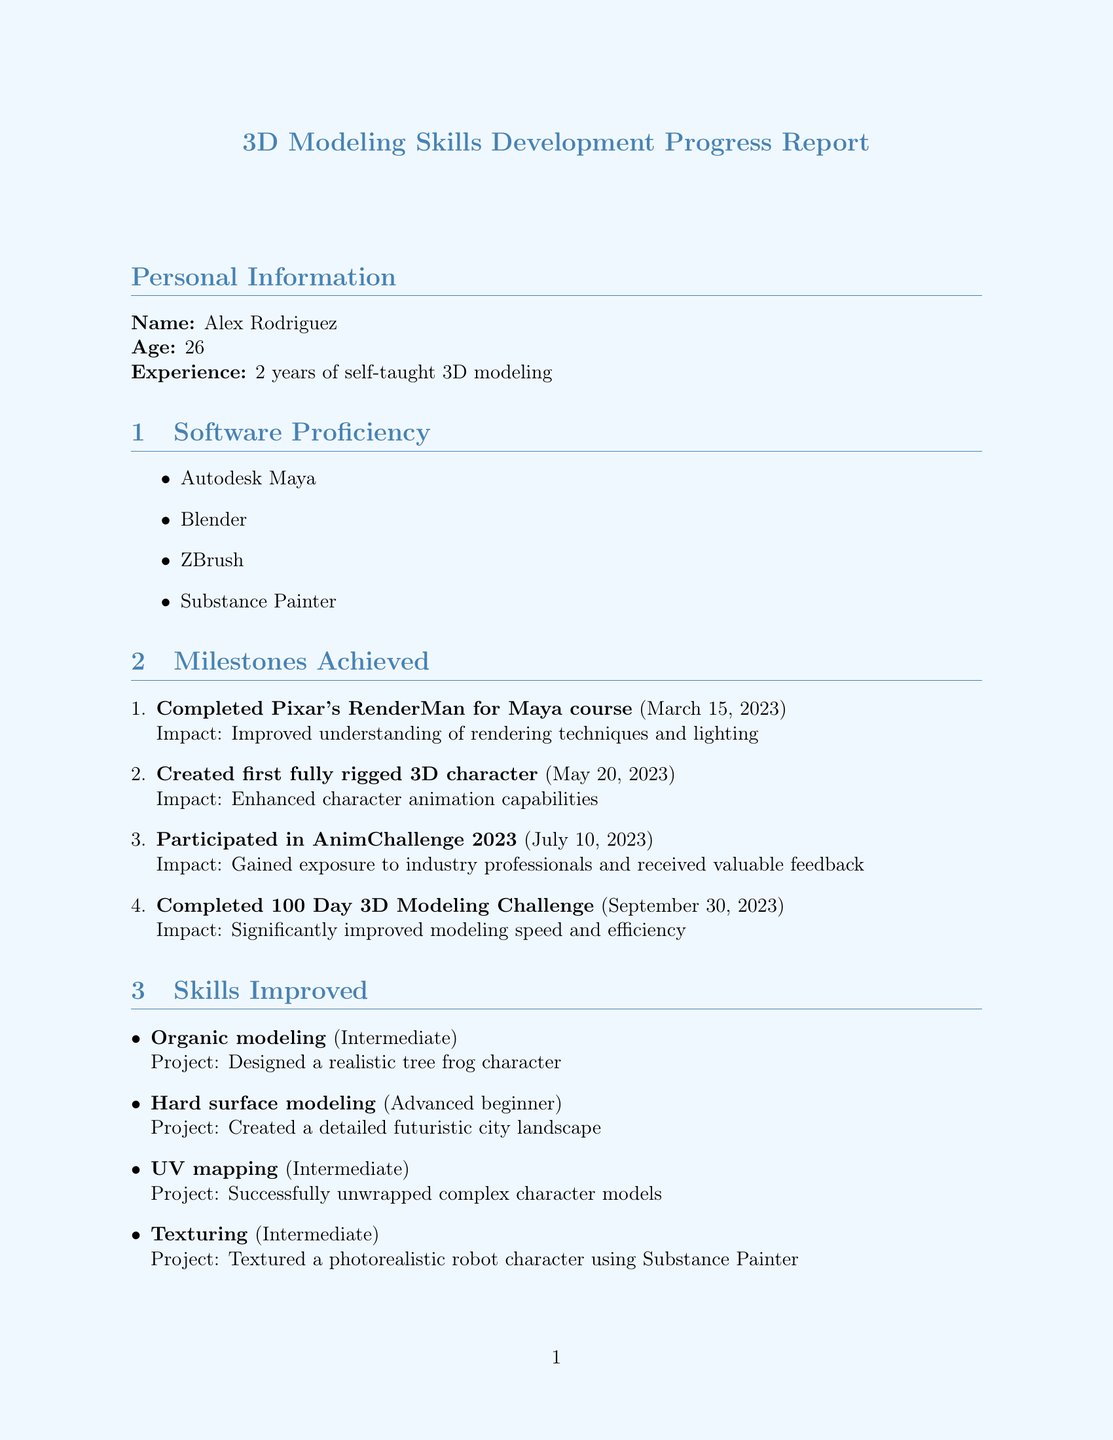What is the name of the individual in the report? The name is listed in the personal information section of the report.
Answer: Alex Rodriguez What software was used for 3D modeling? The list of software used is included under the Software Proficiency section.
Answer: Autodesk Maya, Blender, ZBrush, Substance Painter When did Alex complete the Pixar's RenderMan for Maya course? The completion date for this milestone is mentioned under Milestones Achieved.
Answer: March 15, 2023 What skill level has Alex achieved in UV mapping? The proficiency level is provided in the Skills Improved section.
Answer: Intermediate What is one area for improvement Alex is focusing on? The areas for improvement are listed in a dedicated section of the report.
Answer: Character rigging What is the deadline for creating a 30-second animated short film? This deadline is specified under Upcoming Goals in the report.
Answer: June 30, 2024 How many hours per week does Alex spend using Autodesk Maya? This information is found under the Software Productivity section.
Answer: 20 What type of events has Alex attended for networking? The types of events are detailed in the Industry Connections section of the report.
Answer: Annecy International Animation Film Festival What is a learning resource mentioned in the report? Learning resources are listed in a specific section, detailing their type and usefulness.
Answer: Pluralsight 